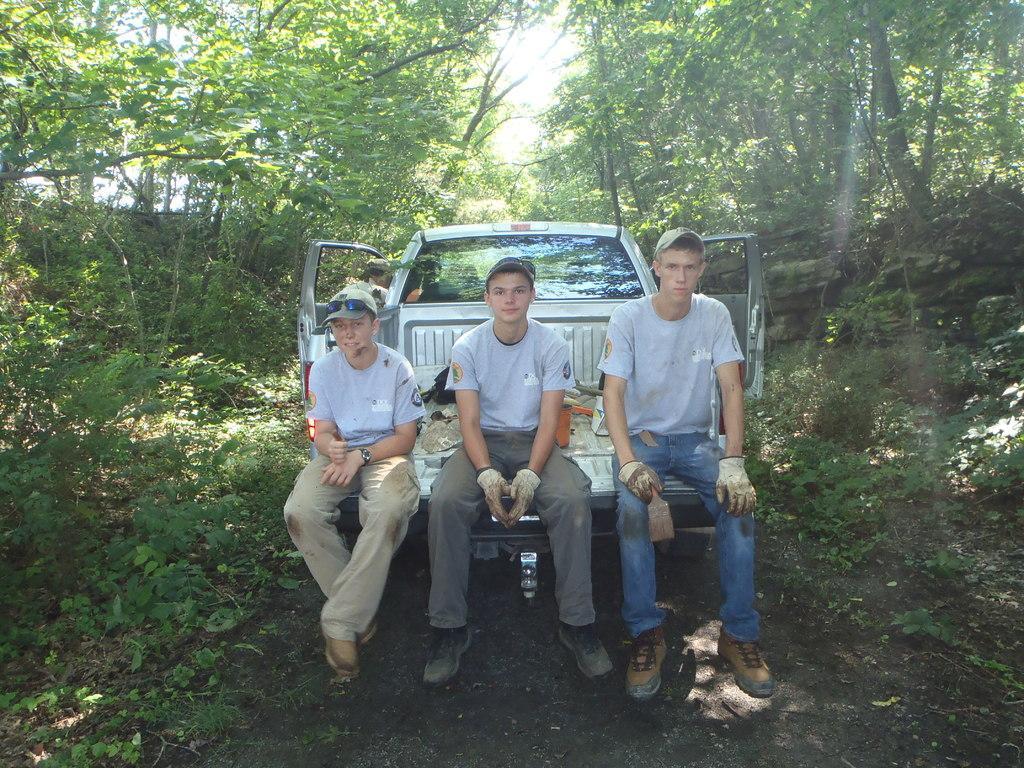Please provide a concise description of this image. In the middle of the image three persons are sitting on the vehicles. Behind the vehicle there are some trees. Behind the trees there is sky. 